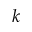<formula> <loc_0><loc_0><loc_500><loc_500>k</formula> 